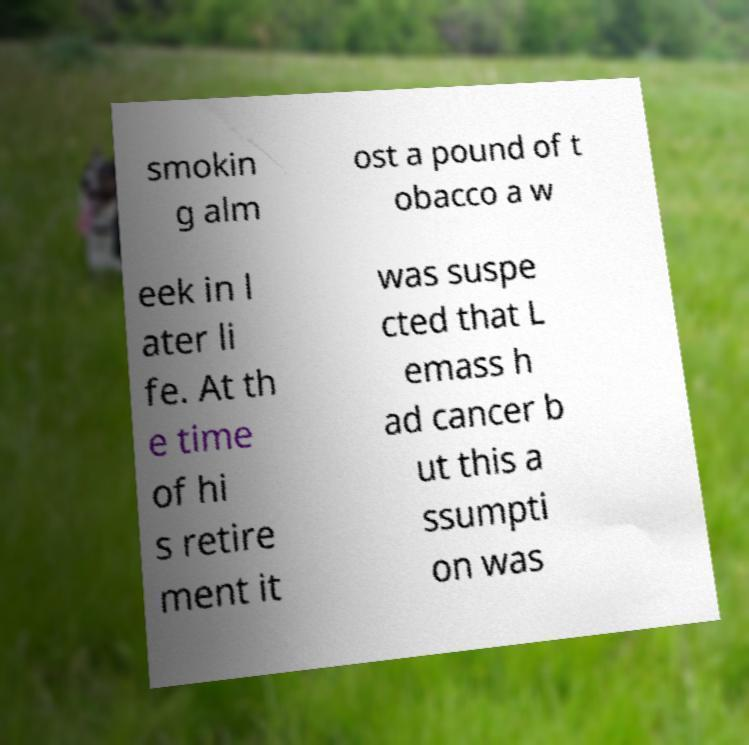Could you assist in decoding the text presented in this image and type it out clearly? smokin g alm ost a pound of t obacco a w eek in l ater li fe. At th e time of hi s retire ment it was suspe cted that L emass h ad cancer b ut this a ssumpti on was 